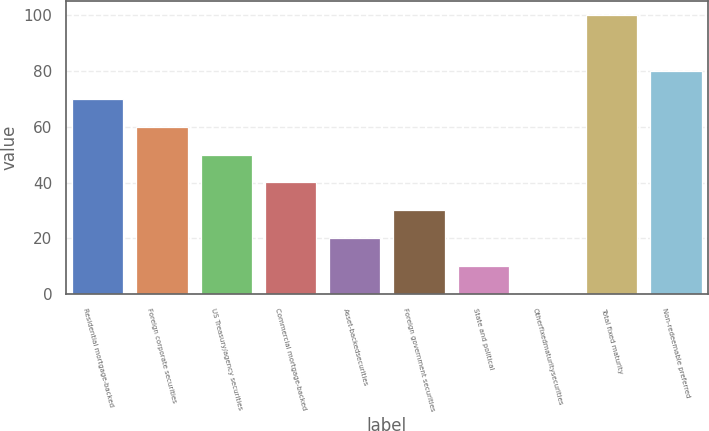<chart> <loc_0><loc_0><loc_500><loc_500><bar_chart><fcel>Residential mortgage-backed<fcel>Foreign corporate securities<fcel>US Treasury/agency securities<fcel>Commercial mortgage-backed<fcel>Asset-backedsecurities<fcel>Foreign government securities<fcel>State and political<fcel>Otherfixedmaturitysecurities<fcel>Total fixed maturity<fcel>Non-redeemable preferred<nl><fcel>70.03<fcel>60.04<fcel>50.05<fcel>40.06<fcel>20.08<fcel>30.07<fcel>10.09<fcel>0.1<fcel>100<fcel>80.02<nl></chart> 